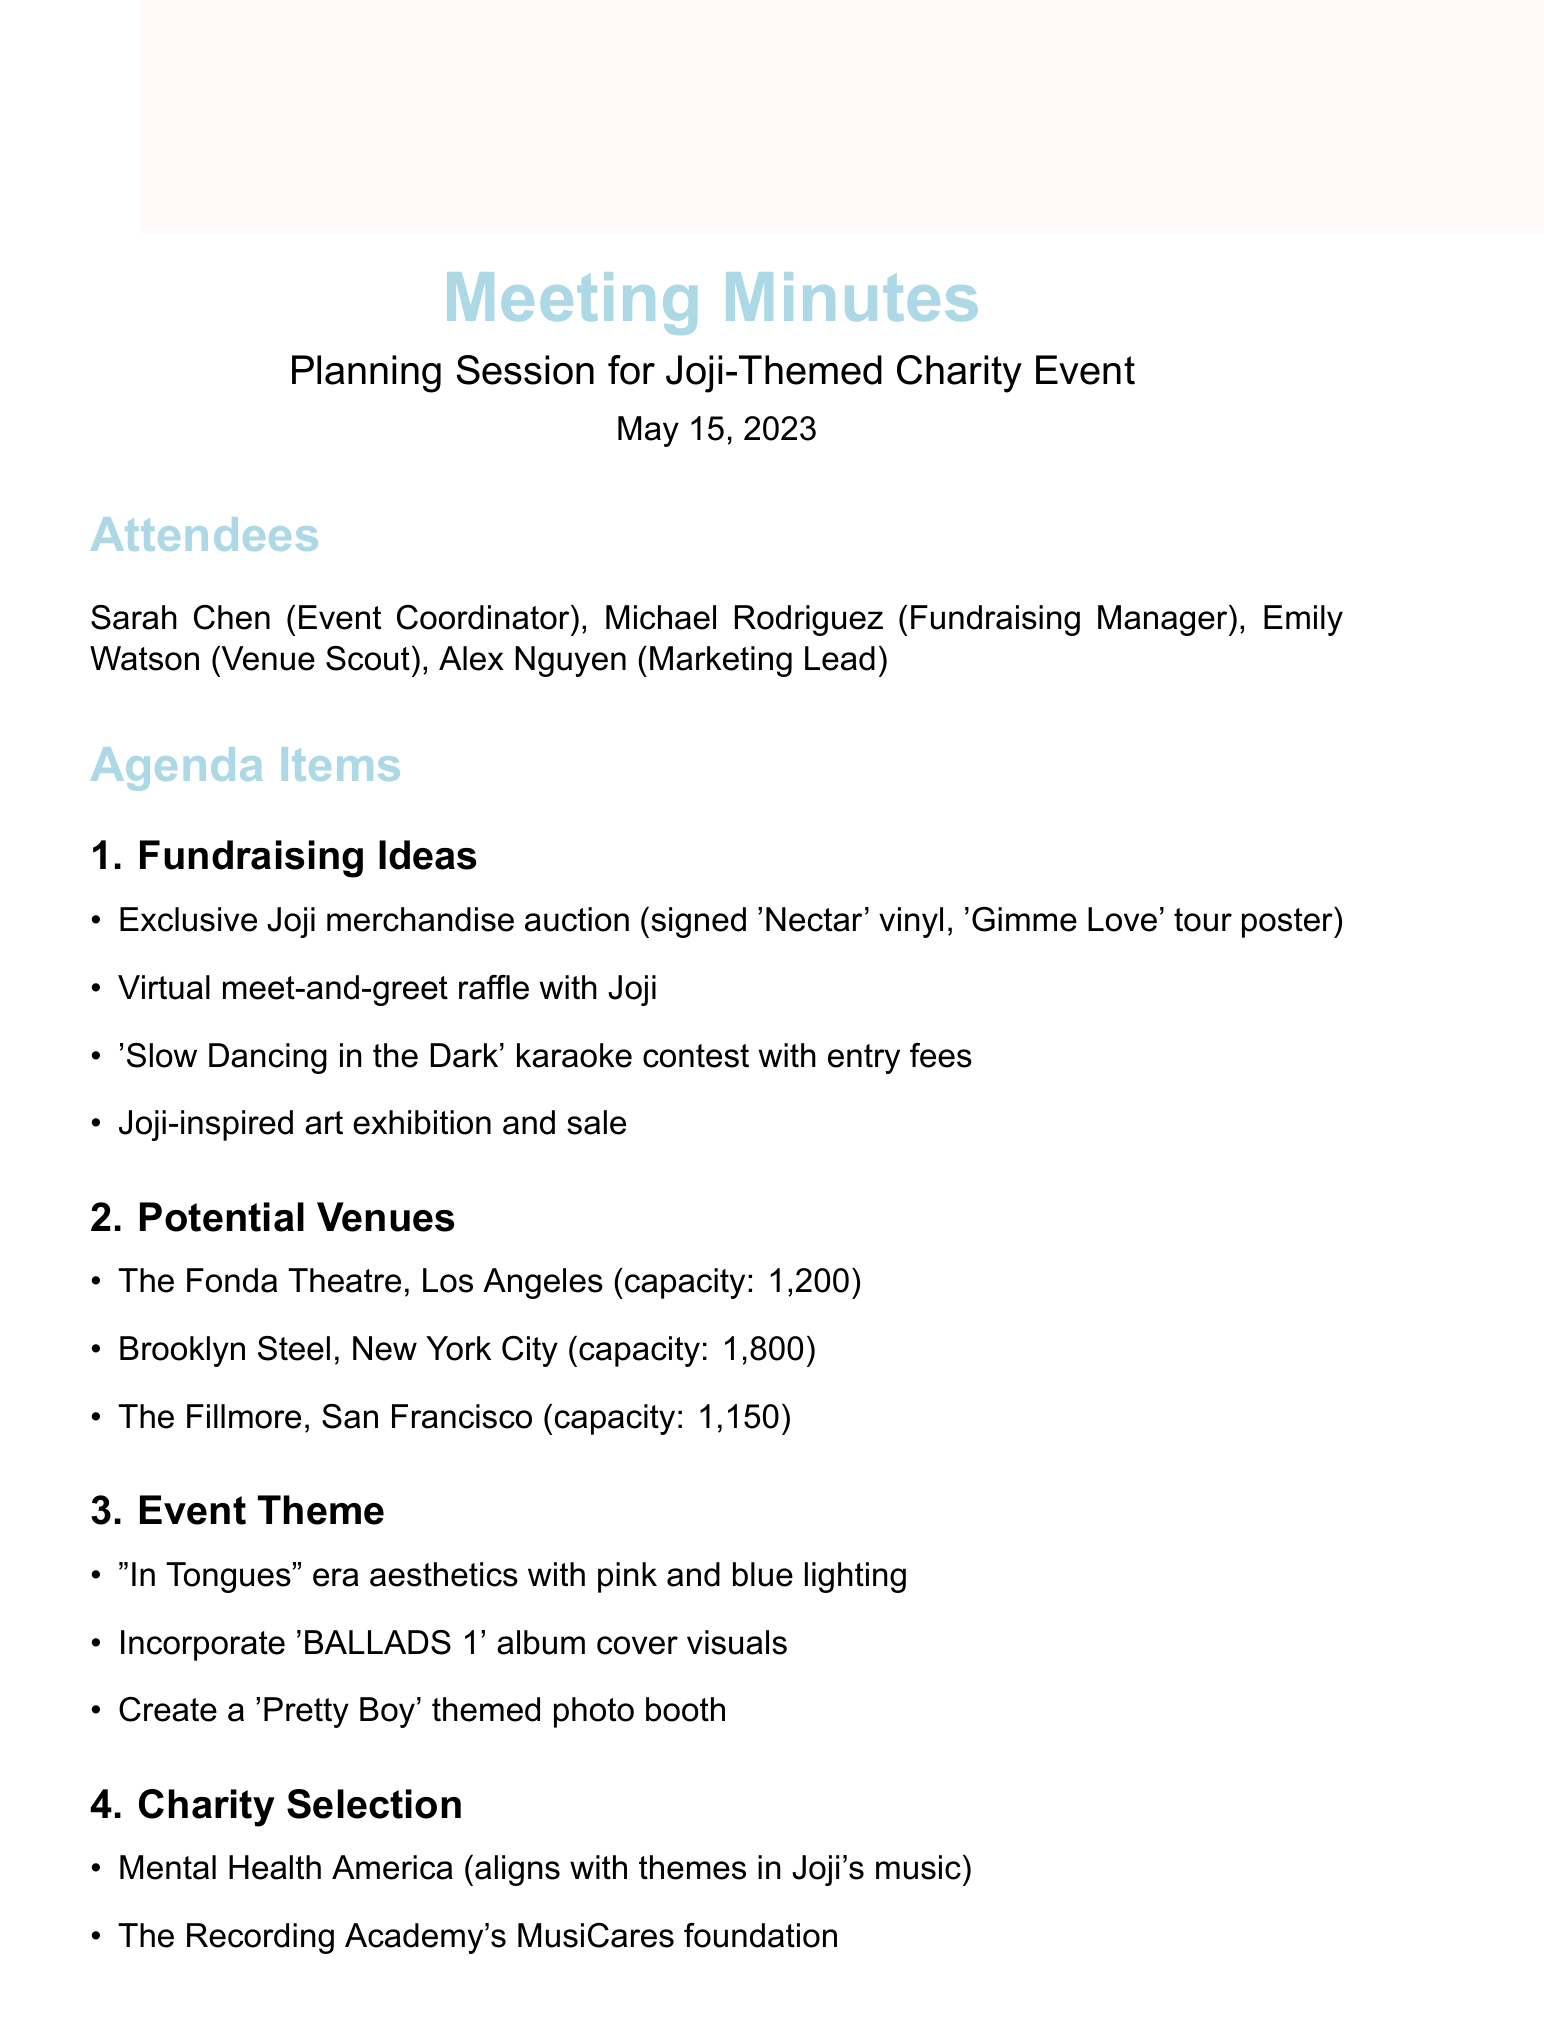What is the date of the meeting? The date of the meeting is explicitly stated in the document as May 15, 2023.
Answer: May 15, 2023 Who is the Fundraising Manager? The document lists attendees, and identifies Michael Rodriguez as the Fundraising Manager.
Answer: Michael Rodriguez What is one of the fundraising ideas mentioned? The document includes several fundraising ideas, one of which is an exclusive merchandise auction.
Answer: Exclusive Joji merchandise auction How many potential venues are listed? The document enumerates three potential venues for the event.
Answer: Three What is the capacity of Brooklyn Steel? The document specifies the capacity of Brooklyn Steel as 1,800.
Answer: 1,800 Which charity aligns with themes in Joji's music? The document names Mental Health America as a charity that aligns with themes in Joji's music.
Answer: Mental Health America What is the event theme aesthetic described? The theme aesthetic detailed in the document is based on the "In Tongues" era with specific lighting colors.
Answer: "In Tongues" era aesthetics with pink and blue lighting Who is responsible for contacting venues? In the action items section, it is stated that Emily is to contact venues for availability and pricing.
Answer: Emily What social media collaboration is suggested for marketing? The document suggests collaborating with 88rising for social media promotion as part of the marketing strategy.
Answer: 88rising 